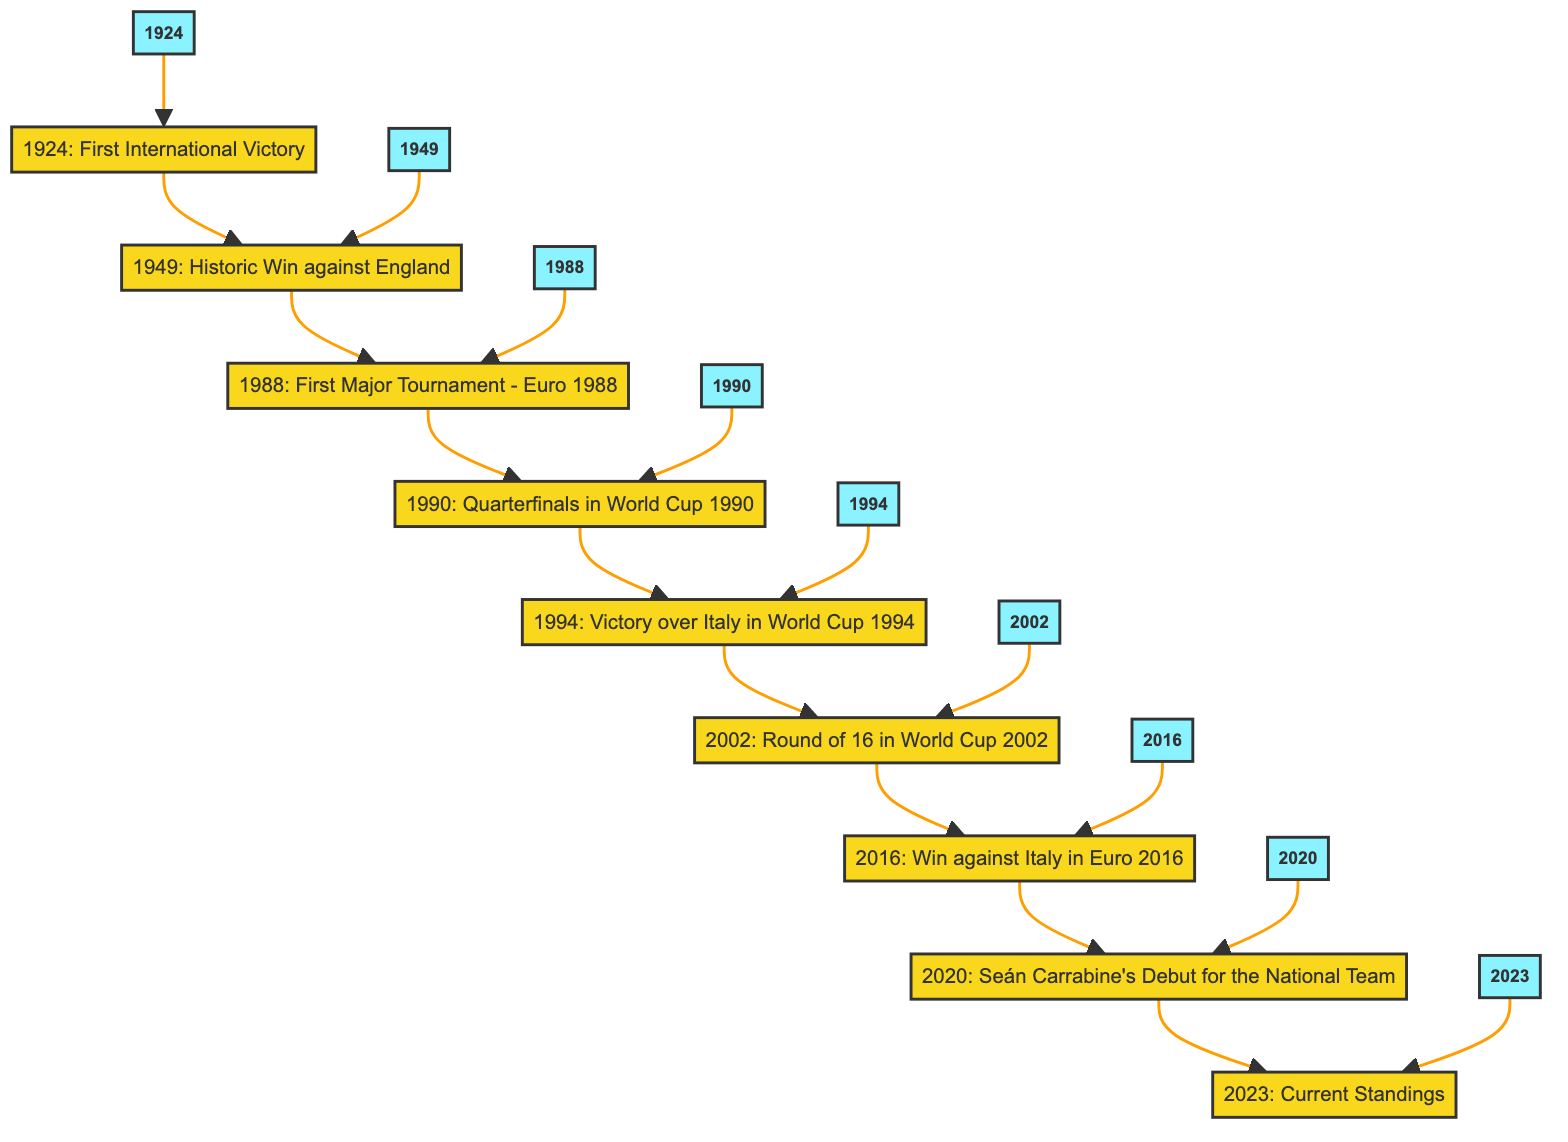What year did Ireland secure its first international victory? The diagram shows the first event at the bottom, which is "First International Victory," dated 1924.
Answer: 1924 What significant match took place in 1949? The second event in the diagram is labeled "Historic Win against England," occurring in 1949.
Answer: Historic Win against England How many major milestones are listed in the timeline? Counting the events in the diagram, there are a total of 9 milestones from 1924 to 2023.
Answer: 9 What was the outcome of Ireland's debut in the World Cup of 1990? In the diagram, the event describes reaching the quarterfinals but mentions defeat by the host nation, Italy.
Answer: Defeated Which event marked Ireland’s first qualification for a major tournament? The event "First Major Tournament - Euro 1988" signifies this achievement, occurring in 1988.
Answer: Euro 1988 In which year did Seán Carrabine make his debut for the national team? The diagram indicates this was in 2020 under the event "Seán Carrabine's Debut for the National Team."
Answer: 2020 What was a notable victory for Ireland in the World Cup of 1994? The event "Victory over Italy in World Cup 1994" indicates obtaining a win against Italy during the group stages in that year.
Answer: Victory over Italy What significant progression did Ireland achieve in the World Cup of 2002? The diagram shows that the event was "Round of 16 in World Cup 2002," indicating a significant achievement in that tournament.
Answer: Round of 16 Which event comes directly before "Current Standings" in the timeline? The event preceding the "Current Standings" (2023) is "Seán Carrabine's Debut for the National Team" (2020), indicating a sequence in the timeline.
Answer: Seán Carrabine's Debut for the National Team 